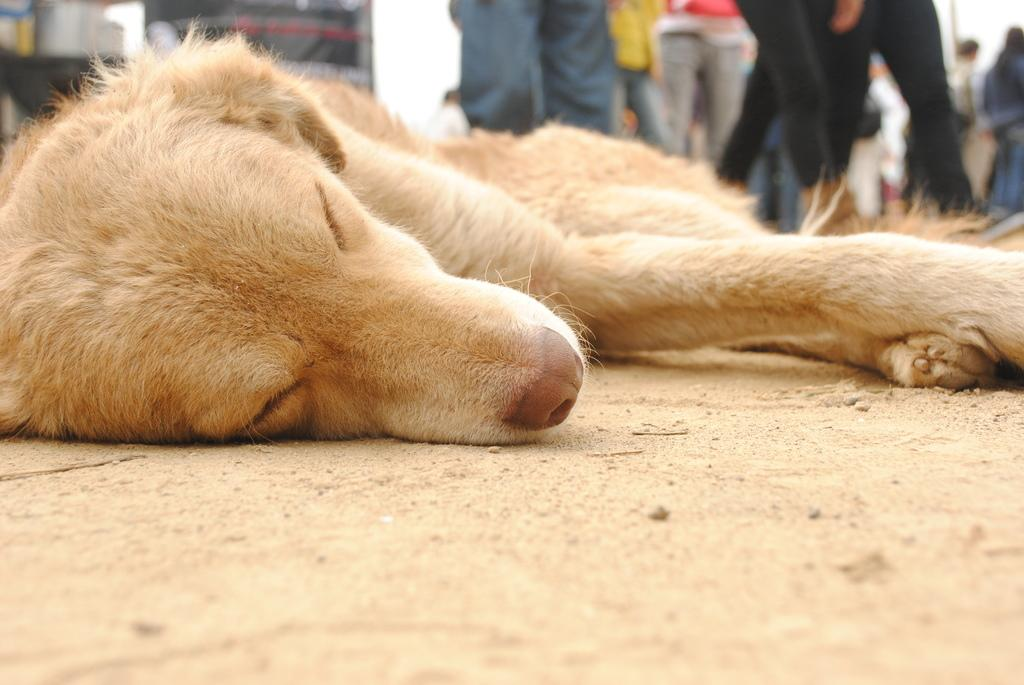What type of animal can be seen in the image? There is a dog in the image. What is the dog doing in the image? The dog is sleeping. Are there any humans present in the image? Yes, there are people visible in the image. What part of the people can be seen in the image? The legs of the people are visible in the image. What is the amount of water in the image? There is no water present in the image. How many times do the people stop in the image? The image does not depict any instances of people stopping, as it only shows their legs. 